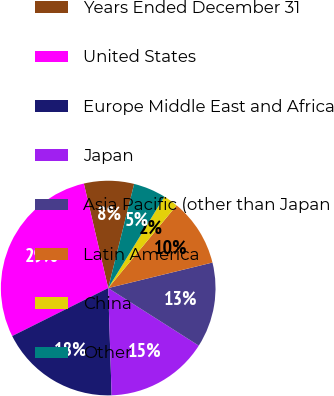<chart> <loc_0><loc_0><loc_500><loc_500><pie_chart><fcel>Years Ended December 31<fcel>United States<fcel>Europe Middle East and Africa<fcel>Japan<fcel>Asia Pacific (other than Japan<fcel>Latin America<fcel>China<fcel>Other<nl><fcel>7.53%<fcel>28.73%<fcel>18.13%<fcel>15.48%<fcel>12.83%<fcel>10.18%<fcel>2.23%<fcel>4.88%<nl></chart> 